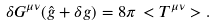<formula> <loc_0><loc_0><loc_500><loc_500>\delta G ^ { \mu \nu } ( { \hat { g } } + \delta g ) = 8 \pi \, < T ^ { \mu \nu } > .</formula> 